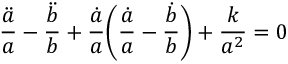Convert formula to latex. <formula><loc_0><loc_0><loc_500><loc_500>\frac { \ddot { a } } { a } - \frac { \ddot { b } } { b } + \frac { \dot { a } } { a } \left ( \frac { \dot { a } } { a } - \frac { \dot { b } } { b } \right ) + \frac { k } { a ^ { 2 } } = 0</formula> 